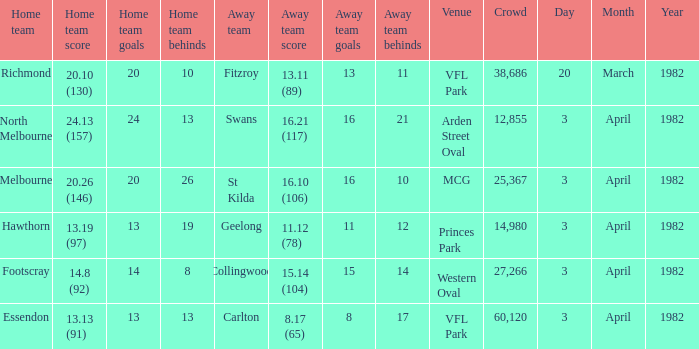When the away team scored 11.12 (78), what was the date of the game? 3 April 1982. 